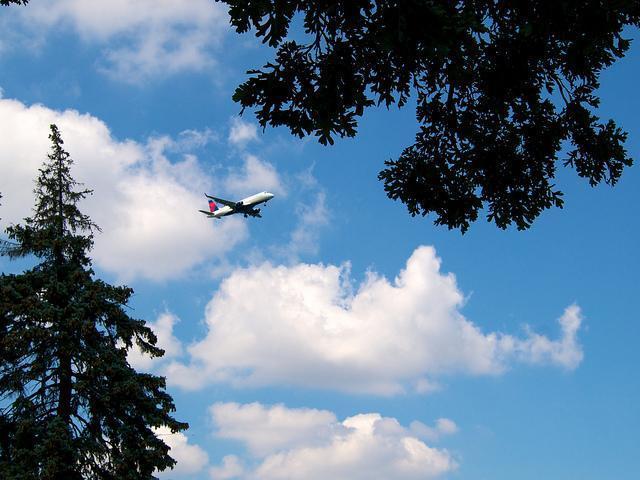How many trees are visible?
Give a very brief answer. 2. How many clouds in this picture?
Give a very brief answer. 4. How many trees are in the picture?
Give a very brief answer. 2. How many people are wearing a blue wig?
Give a very brief answer. 0. 